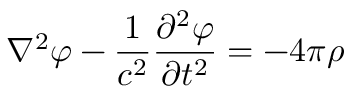Convert formula to latex. <formula><loc_0><loc_0><loc_500><loc_500>\nabla ^ { 2 } \varphi - { \frac { 1 } { c ^ { 2 } } } { \frac { \partial ^ { 2 } \varphi } { \partial t ^ { 2 } } } = - { 4 \pi \rho }</formula> 